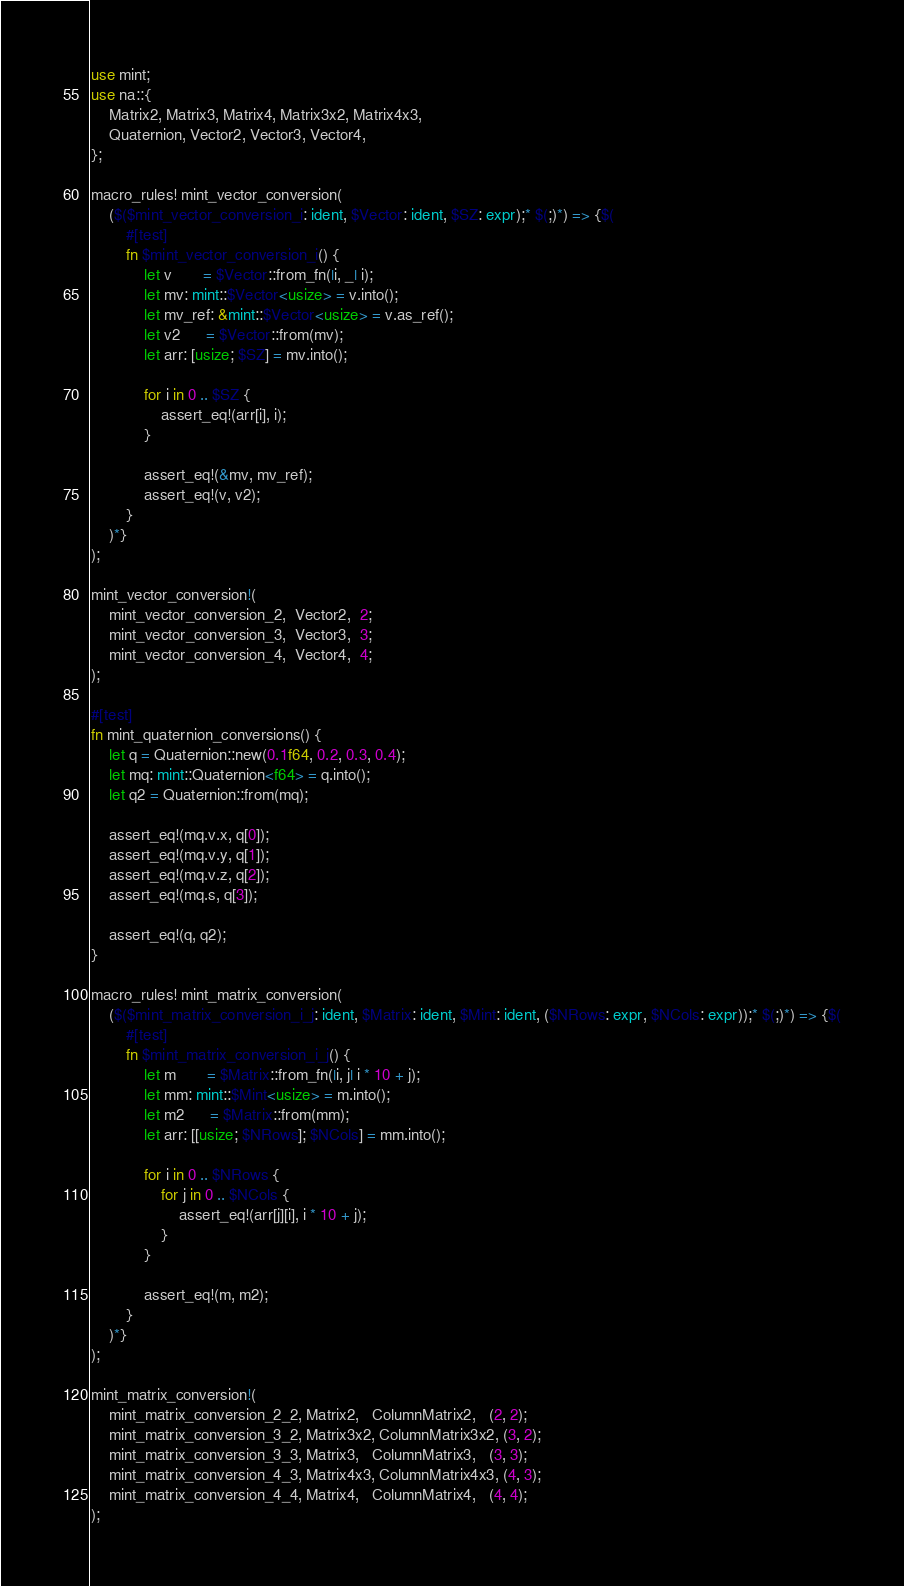Convert code to text. <code><loc_0><loc_0><loc_500><loc_500><_Rust_>use mint;
use na::{
    Matrix2, Matrix3, Matrix4, Matrix3x2, Matrix4x3,
    Quaternion, Vector2, Vector3, Vector4,
};

macro_rules! mint_vector_conversion(
    ($($mint_vector_conversion_i: ident, $Vector: ident, $SZ: expr);* $(;)*) => {$(
        #[test]
        fn $mint_vector_conversion_i() {
            let v       = $Vector::from_fn(|i, _| i);
            let mv: mint::$Vector<usize> = v.into();
            let mv_ref: &mint::$Vector<usize> = v.as_ref();
            let v2      = $Vector::from(mv);
            let arr: [usize; $SZ] = mv.into();

            for i in 0 .. $SZ {
                assert_eq!(arr[i], i);
            }

            assert_eq!(&mv, mv_ref);
            assert_eq!(v, v2);
        }
    )*}
);

mint_vector_conversion!(
    mint_vector_conversion_2,  Vector2,  2;
    mint_vector_conversion_3,  Vector3,  3;
    mint_vector_conversion_4,  Vector4,  4;
);

#[test]
fn mint_quaternion_conversions() {
    let q = Quaternion::new(0.1f64, 0.2, 0.3, 0.4);
    let mq: mint::Quaternion<f64> = q.into();
    let q2 = Quaternion::from(mq);

    assert_eq!(mq.v.x, q[0]);
    assert_eq!(mq.v.y, q[1]);
    assert_eq!(mq.v.z, q[2]);
    assert_eq!(mq.s, q[3]);

    assert_eq!(q, q2);
}

macro_rules! mint_matrix_conversion(
    ($($mint_matrix_conversion_i_j: ident, $Matrix: ident, $Mint: ident, ($NRows: expr, $NCols: expr));* $(;)*) => {$(
        #[test]
        fn $mint_matrix_conversion_i_j() {
            let m       = $Matrix::from_fn(|i, j| i * 10 + j);
            let mm: mint::$Mint<usize> = m.into();
            let m2      = $Matrix::from(mm);
            let arr: [[usize; $NRows]; $NCols] = mm.into();

            for i in 0 .. $NRows {
                for j in 0 .. $NCols {
                    assert_eq!(arr[j][i], i * 10 + j);
                }
            }

            assert_eq!(m, m2);
        }
    )*}
);

mint_matrix_conversion!(
    mint_matrix_conversion_2_2, Matrix2,   ColumnMatrix2,   (2, 2);
    mint_matrix_conversion_3_2, Matrix3x2, ColumnMatrix3x2, (3, 2);
    mint_matrix_conversion_3_3, Matrix3,   ColumnMatrix3,   (3, 3);
    mint_matrix_conversion_4_3, Matrix4x3, ColumnMatrix4x3, (4, 3);
    mint_matrix_conversion_4_4, Matrix4,   ColumnMatrix4,   (4, 4);
);
</code> 